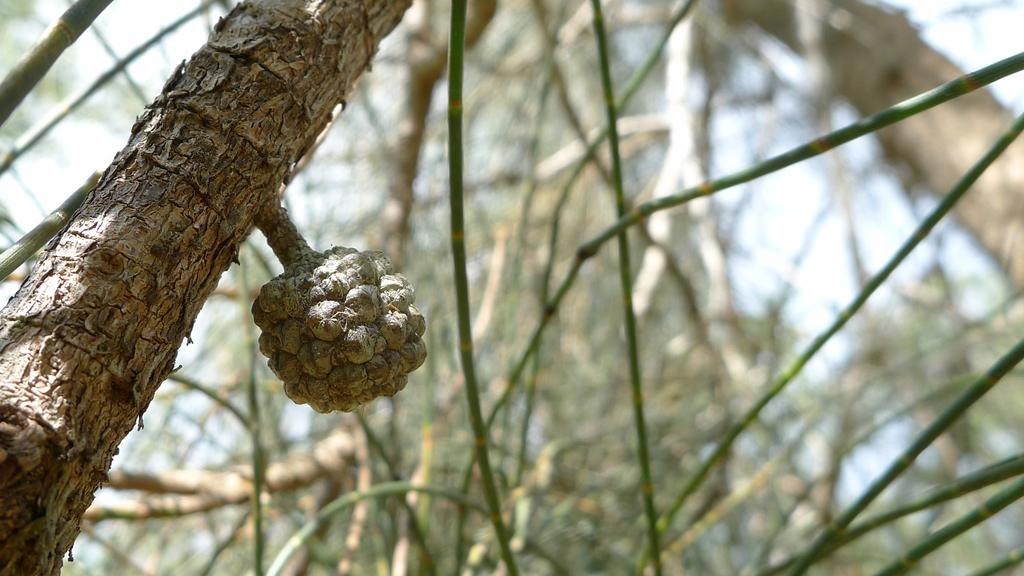What object is the main focus of the image? There is a trunk in the image. What can be seen in the background of the image? There are trees in the background of the image. What is the color of the trees in the image? The trees are green in color. What is the color of the sky in the image? The sky is white in color. How many mint leaves are growing on the trunk in the image? There are no mint leaves present in the image; it only features a trunk and trees in the background. 